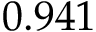Convert formula to latex. <formula><loc_0><loc_0><loc_500><loc_500>0 . 9 4 1</formula> 